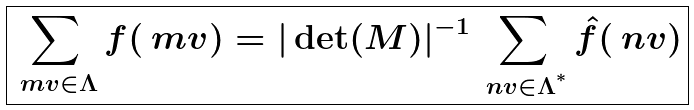<formula> <loc_0><loc_0><loc_500><loc_500>\boxed { \sum _ { \ m v \in \Lambda } f ( \ m v ) = | \det ( M ) | ^ { - 1 } \sum _ { \ n v \in \Lambda ^ { ^ { * } } } \hat { f } ( \ n v ) }</formula> 